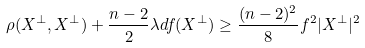<formula> <loc_0><loc_0><loc_500><loc_500>\rho ( X ^ { \bot } , X ^ { \bot } ) + \frac { n - 2 } { 2 } \lambda d f ( X ^ { \bot } ) \geq \frac { ( n - 2 ) ^ { 2 } } { 8 } f ^ { 2 } | X ^ { \bot } | ^ { 2 }</formula> 